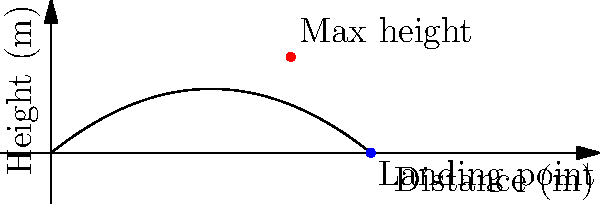In a javelin throw competition, the trajectory of your throw is represented by the function $h(x) = -0.05x^2 + 0.8x$, where $h$ is the height in meters and $x$ is the horizontal distance in meters. What is the maximum distance the javelin travels before hitting the ground? To find the maximum distance, we need to determine where the javelin's height becomes zero again after being thrown. This occurs when $h(x) = 0$.

Let's solve the equation:

1) $-0.05x^2 + 0.8x = 0$

2) Factor out $x$: $x(-0.05x + 0.8) = 0$

3) Using the zero product property, we get two solutions:
   $x = 0$ or $-0.05x + 0.8 = 0$

4) $x = 0$ represents the starting point, so we solve the second equation:
   $-0.05x + 0.8 = 0$
   $-0.05x = -0.8$
   $x = 16$

5) Therefore, the javelin hits the ground at $x = 16$ meters.

This result is consistent with the graph, where we can see the curve intersecting the x-axis at 16 meters.
Answer: 16 meters 